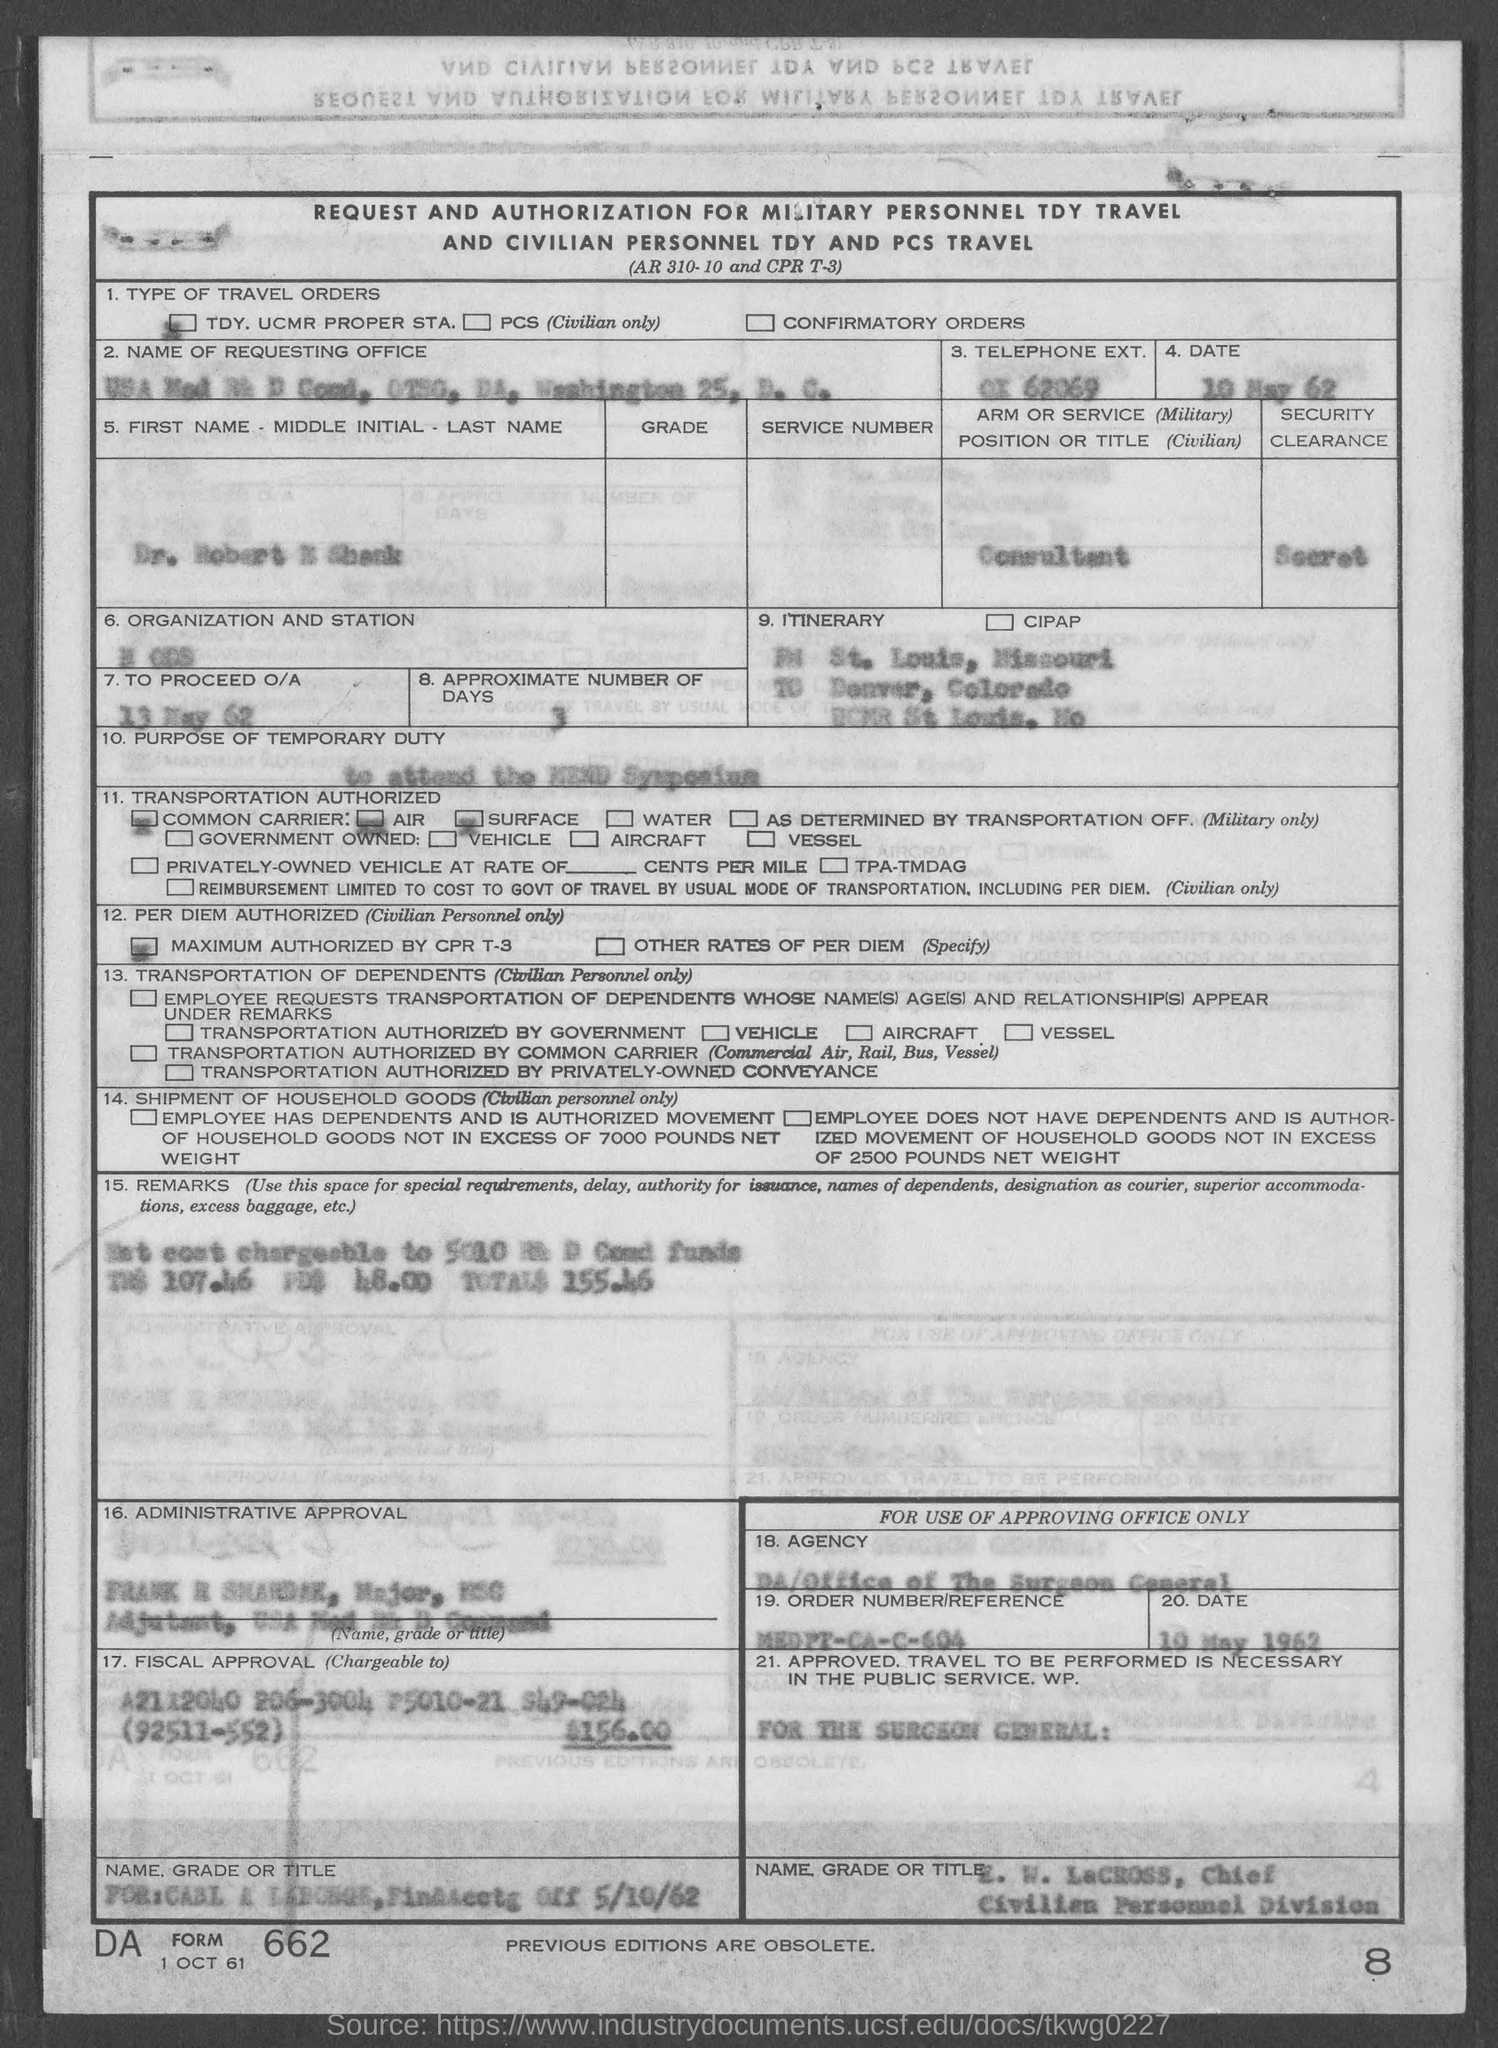Indicate a few pertinent items in this graphic. The date mentioned in the given form is May 13, 1962, and as per the instructions, the O/A process should commence. 